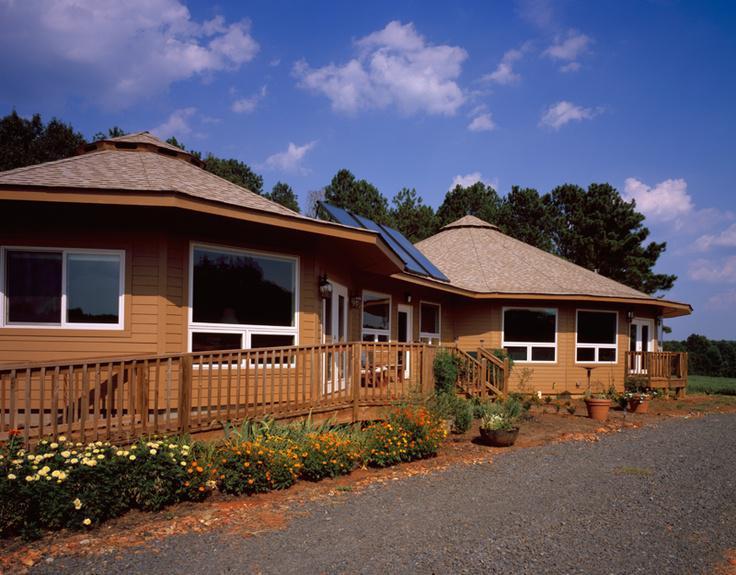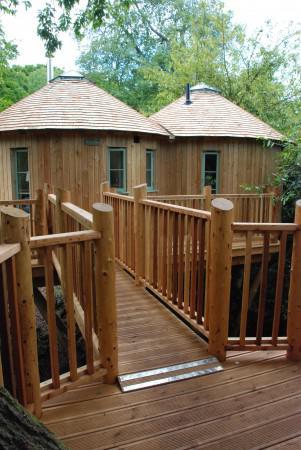The first image is the image on the left, the second image is the image on the right. For the images shown, is this caption "One image shows the interior of a large yurt with the framework of three small side-by-side yurts in the rear and a skylight overhead." true? Answer yes or no. No. The first image is the image on the left, the second image is the image on the right. Assess this claim about the two images: "An image shows an interior with three side-by-side lattice-work dome-topped structural elements visible.". Correct or not? Answer yes or no. No. 